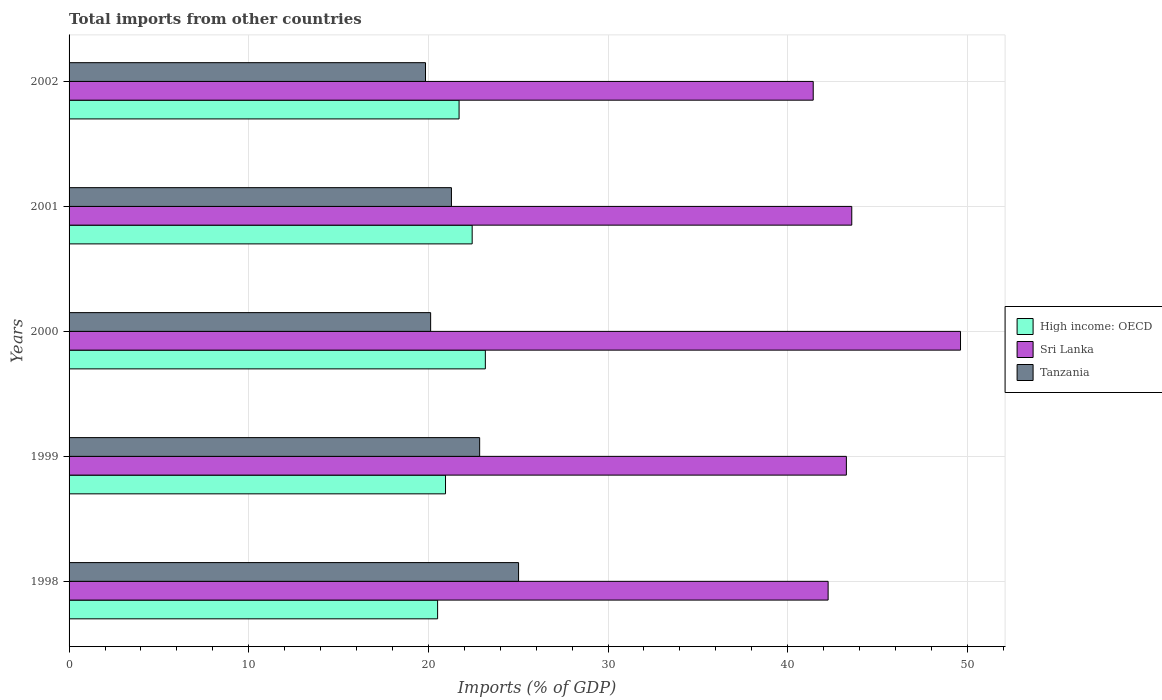How many bars are there on the 2nd tick from the top?
Offer a terse response. 3. How many bars are there on the 2nd tick from the bottom?
Provide a succinct answer. 3. What is the label of the 3rd group of bars from the top?
Keep it short and to the point. 2000. In how many cases, is the number of bars for a given year not equal to the number of legend labels?
Keep it short and to the point. 0. What is the total imports in Sri Lanka in 1999?
Provide a short and direct response. 43.27. Across all years, what is the maximum total imports in Sri Lanka?
Provide a succinct answer. 49.62. Across all years, what is the minimum total imports in High income: OECD?
Provide a short and direct response. 20.51. In which year was the total imports in Tanzania maximum?
Provide a succinct answer. 1998. In which year was the total imports in Tanzania minimum?
Offer a terse response. 2002. What is the total total imports in Tanzania in the graph?
Make the answer very short. 109.12. What is the difference between the total imports in Tanzania in 1998 and that in 1999?
Your response must be concise. 2.17. What is the difference between the total imports in Tanzania in 2000 and the total imports in Sri Lanka in 1999?
Make the answer very short. -23.14. What is the average total imports in Tanzania per year?
Your response must be concise. 21.82. In the year 2001, what is the difference between the total imports in Sri Lanka and total imports in High income: OECD?
Ensure brevity in your answer.  21.13. In how many years, is the total imports in Tanzania greater than 38 %?
Your answer should be compact. 0. What is the ratio of the total imports in Sri Lanka in 1998 to that in 2000?
Provide a succinct answer. 0.85. What is the difference between the highest and the second highest total imports in High income: OECD?
Ensure brevity in your answer.  0.73. What is the difference between the highest and the lowest total imports in High income: OECD?
Offer a terse response. 2.66. Is the sum of the total imports in High income: OECD in 2001 and 2002 greater than the maximum total imports in Tanzania across all years?
Provide a succinct answer. Yes. What does the 2nd bar from the top in 2000 represents?
Provide a succinct answer. Sri Lanka. What does the 3rd bar from the bottom in 2002 represents?
Offer a terse response. Tanzania. Is it the case that in every year, the sum of the total imports in Sri Lanka and total imports in High income: OECD is greater than the total imports in Tanzania?
Your answer should be compact. Yes. How many years are there in the graph?
Your response must be concise. 5. Are the values on the major ticks of X-axis written in scientific E-notation?
Your response must be concise. No. Does the graph contain any zero values?
Provide a short and direct response. No. How many legend labels are there?
Keep it short and to the point. 3. What is the title of the graph?
Your answer should be very brief. Total imports from other countries. Does "Dominica" appear as one of the legend labels in the graph?
Make the answer very short. No. What is the label or title of the X-axis?
Provide a succinct answer. Imports (% of GDP). What is the Imports (% of GDP) in High income: OECD in 1998?
Keep it short and to the point. 20.51. What is the Imports (% of GDP) in Sri Lanka in 1998?
Your response must be concise. 42.25. What is the Imports (% of GDP) in Tanzania in 1998?
Your answer should be compact. 25.02. What is the Imports (% of GDP) in High income: OECD in 1999?
Offer a terse response. 20.95. What is the Imports (% of GDP) in Sri Lanka in 1999?
Give a very brief answer. 43.27. What is the Imports (% of GDP) in Tanzania in 1999?
Give a very brief answer. 22.85. What is the Imports (% of GDP) in High income: OECD in 2000?
Offer a very short reply. 23.17. What is the Imports (% of GDP) of Sri Lanka in 2000?
Offer a terse response. 49.62. What is the Imports (% of GDP) in Tanzania in 2000?
Your answer should be compact. 20.13. What is the Imports (% of GDP) in High income: OECD in 2001?
Offer a terse response. 22.44. What is the Imports (% of GDP) in Sri Lanka in 2001?
Provide a short and direct response. 43.57. What is the Imports (% of GDP) of Tanzania in 2001?
Make the answer very short. 21.28. What is the Imports (% of GDP) of High income: OECD in 2002?
Your answer should be compact. 21.71. What is the Imports (% of GDP) in Sri Lanka in 2002?
Your answer should be compact. 41.42. What is the Imports (% of GDP) of Tanzania in 2002?
Offer a very short reply. 19.84. Across all years, what is the maximum Imports (% of GDP) of High income: OECD?
Keep it short and to the point. 23.17. Across all years, what is the maximum Imports (% of GDP) in Sri Lanka?
Provide a short and direct response. 49.62. Across all years, what is the maximum Imports (% of GDP) of Tanzania?
Offer a terse response. 25.02. Across all years, what is the minimum Imports (% of GDP) of High income: OECD?
Your response must be concise. 20.51. Across all years, what is the minimum Imports (% of GDP) of Sri Lanka?
Offer a very short reply. 41.42. Across all years, what is the minimum Imports (% of GDP) in Tanzania?
Provide a succinct answer. 19.84. What is the total Imports (% of GDP) in High income: OECD in the graph?
Offer a very short reply. 108.79. What is the total Imports (% of GDP) of Sri Lanka in the graph?
Offer a terse response. 220.13. What is the total Imports (% of GDP) of Tanzania in the graph?
Make the answer very short. 109.12. What is the difference between the Imports (% of GDP) of High income: OECD in 1998 and that in 1999?
Give a very brief answer. -0.44. What is the difference between the Imports (% of GDP) of Sri Lanka in 1998 and that in 1999?
Keep it short and to the point. -1.02. What is the difference between the Imports (% of GDP) of Tanzania in 1998 and that in 1999?
Make the answer very short. 2.17. What is the difference between the Imports (% of GDP) of High income: OECD in 1998 and that in 2000?
Ensure brevity in your answer.  -2.66. What is the difference between the Imports (% of GDP) of Sri Lanka in 1998 and that in 2000?
Give a very brief answer. -7.37. What is the difference between the Imports (% of GDP) of Tanzania in 1998 and that in 2000?
Provide a succinct answer. 4.89. What is the difference between the Imports (% of GDP) in High income: OECD in 1998 and that in 2001?
Give a very brief answer. -1.92. What is the difference between the Imports (% of GDP) in Sri Lanka in 1998 and that in 2001?
Provide a short and direct response. -1.32. What is the difference between the Imports (% of GDP) of Tanzania in 1998 and that in 2001?
Make the answer very short. 3.74. What is the difference between the Imports (% of GDP) of High income: OECD in 1998 and that in 2002?
Provide a short and direct response. -1.19. What is the difference between the Imports (% of GDP) in Sri Lanka in 1998 and that in 2002?
Your response must be concise. 0.83. What is the difference between the Imports (% of GDP) of Tanzania in 1998 and that in 2002?
Offer a very short reply. 5.18. What is the difference between the Imports (% of GDP) of High income: OECD in 1999 and that in 2000?
Offer a terse response. -2.22. What is the difference between the Imports (% of GDP) in Sri Lanka in 1999 and that in 2000?
Offer a very short reply. -6.35. What is the difference between the Imports (% of GDP) of Tanzania in 1999 and that in 2000?
Ensure brevity in your answer.  2.73. What is the difference between the Imports (% of GDP) in High income: OECD in 1999 and that in 2001?
Provide a short and direct response. -1.48. What is the difference between the Imports (% of GDP) of Sri Lanka in 1999 and that in 2001?
Make the answer very short. -0.3. What is the difference between the Imports (% of GDP) in Tanzania in 1999 and that in 2001?
Offer a terse response. 1.57. What is the difference between the Imports (% of GDP) of High income: OECD in 1999 and that in 2002?
Give a very brief answer. -0.75. What is the difference between the Imports (% of GDP) of Sri Lanka in 1999 and that in 2002?
Keep it short and to the point. 1.85. What is the difference between the Imports (% of GDP) of Tanzania in 1999 and that in 2002?
Make the answer very short. 3.01. What is the difference between the Imports (% of GDP) of High income: OECD in 2000 and that in 2001?
Your response must be concise. 0.73. What is the difference between the Imports (% of GDP) of Sri Lanka in 2000 and that in 2001?
Ensure brevity in your answer.  6.05. What is the difference between the Imports (% of GDP) of Tanzania in 2000 and that in 2001?
Give a very brief answer. -1.16. What is the difference between the Imports (% of GDP) in High income: OECD in 2000 and that in 2002?
Provide a succinct answer. 1.46. What is the difference between the Imports (% of GDP) in Sri Lanka in 2000 and that in 2002?
Give a very brief answer. 8.2. What is the difference between the Imports (% of GDP) of Tanzania in 2000 and that in 2002?
Offer a terse response. 0.29. What is the difference between the Imports (% of GDP) of High income: OECD in 2001 and that in 2002?
Your answer should be very brief. 0.73. What is the difference between the Imports (% of GDP) of Sri Lanka in 2001 and that in 2002?
Offer a very short reply. 2.15. What is the difference between the Imports (% of GDP) of Tanzania in 2001 and that in 2002?
Provide a succinct answer. 1.44. What is the difference between the Imports (% of GDP) of High income: OECD in 1998 and the Imports (% of GDP) of Sri Lanka in 1999?
Your response must be concise. -22.75. What is the difference between the Imports (% of GDP) of High income: OECD in 1998 and the Imports (% of GDP) of Tanzania in 1999?
Keep it short and to the point. -2.34. What is the difference between the Imports (% of GDP) of Sri Lanka in 1998 and the Imports (% of GDP) of Tanzania in 1999?
Your response must be concise. 19.4. What is the difference between the Imports (% of GDP) in High income: OECD in 1998 and the Imports (% of GDP) in Sri Lanka in 2000?
Give a very brief answer. -29.11. What is the difference between the Imports (% of GDP) in High income: OECD in 1998 and the Imports (% of GDP) in Tanzania in 2000?
Make the answer very short. 0.39. What is the difference between the Imports (% of GDP) of Sri Lanka in 1998 and the Imports (% of GDP) of Tanzania in 2000?
Provide a succinct answer. 22.13. What is the difference between the Imports (% of GDP) of High income: OECD in 1998 and the Imports (% of GDP) of Sri Lanka in 2001?
Offer a very short reply. -23.05. What is the difference between the Imports (% of GDP) in High income: OECD in 1998 and the Imports (% of GDP) in Tanzania in 2001?
Your response must be concise. -0.77. What is the difference between the Imports (% of GDP) of Sri Lanka in 1998 and the Imports (% of GDP) of Tanzania in 2001?
Your answer should be very brief. 20.97. What is the difference between the Imports (% of GDP) in High income: OECD in 1998 and the Imports (% of GDP) in Sri Lanka in 2002?
Provide a short and direct response. -20.91. What is the difference between the Imports (% of GDP) in High income: OECD in 1998 and the Imports (% of GDP) in Tanzania in 2002?
Your answer should be compact. 0.67. What is the difference between the Imports (% of GDP) in Sri Lanka in 1998 and the Imports (% of GDP) in Tanzania in 2002?
Keep it short and to the point. 22.41. What is the difference between the Imports (% of GDP) in High income: OECD in 1999 and the Imports (% of GDP) in Sri Lanka in 2000?
Ensure brevity in your answer.  -28.67. What is the difference between the Imports (% of GDP) of High income: OECD in 1999 and the Imports (% of GDP) of Tanzania in 2000?
Give a very brief answer. 0.83. What is the difference between the Imports (% of GDP) of Sri Lanka in 1999 and the Imports (% of GDP) of Tanzania in 2000?
Provide a short and direct response. 23.14. What is the difference between the Imports (% of GDP) of High income: OECD in 1999 and the Imports (% of GDP) of Sri Lanka in 2001?
Offer a very short reply. -22.61. What is the difference between the Imports (% of GDP) of High income: OECD in 1999 and the Imports (% of GDP) of Tanzania in 2001?
Ensure brevity in your answer.  -0.33. What is the difference between the Imports (% of GDP) in Sri Lanka in 1999 and the Imports (% of GDP) in Tanzania in 2001?
Make the answer very short. 21.98. What is the difference between the Imports (% of GDP) in High income: OECD in 1999 and the Imports (% of GDP) in Sri Lanka in 2002?
Your response must be concise. -20.47. What is the difference between the Imports (% of GDP) in High income: OECD in 1999 and the Imports (% of GDP) in Tanzania in 2002?
Offer a very short reply. 1.11. What is the difference between the Imports (% of GDP) of Sri Lanka in 1999 and the Imports (% of GDP) of Tanzania in 2002?
Provide a short and direct response. 23.43. What is the difference between the Imports (% of GDP) in High income: OECD in 2000 and the Imports (% of GDP) in Sri Lanka in 2001?
Provide a short and direct response. -20.4. What is the difference between the Imports (% of GDP) in High income: OECD in 2000 and the Imports (% of GDP) in Tanzania in 2001?
Your answer should be compact. 1.89. What is the difference between the Imports (% of GDP) of Sri Lanka in 2000 and the Imports (% of GDP) of Tanzania in 2001?
Provide a succinct answer. 28.34. What is the difference between the Imports (% of GDP) of High income: OECD in 2000 and the Imports (% of GDP) of Sri Lanka in 2002?
Offer a very short reply. -18.25. What is the difference between the Imports (% of GDP) of High income: OECD in 2000 and the Imports (% of GDP) of Tanzania in 2002?
Your answer should be very brief. 3.33. What is the difference between the Imports (% of GDP) of Sri Lanka in 2000 and the Imports (% of GDP) of Tanzania in 2002?
Your answer should be very brief. 29.78. What is the difference between the Imports (% of GDP) of High income: OECD in 2001 and the Imports (% of GDP) of Sri Lanka in 2002?
Ensure brevity in your answer.  -18.98. What is the difference between the Imports (% of GDP) of High income: OECD in 2001 and the Imports (% of GDP) of Tanzania in 2002?
Offer a very short reply. 2.6. What is the difference between the Imports (% of GDP) in Sri Lanka in 2001 and the Imports (% of GDP) in Tanzania in 2002?
Provide a short and direct response. 23.73. What is the average Imports (% of GDP) in High income: OECD per year?
Your response must be concise. 21.76. What is the average Imports (% of GDP) of Sri Lanka per year?
Your response must be concise. 44.03. What is the average Imports (% of GDP) in Tanzania per year?
Your answer should be compact. 21.82. In the year 1998, what is the difference between the Imports (% of GDP) of High income: OECD and Imports (% of GDP) of Sri Lanka?
Offer a terse response. -21.74. In the year 1998, what is the difference between the Imports (% of GDP) in High income: OECD and Imports (% of GDP) in Tanzania?
Your answer should be compact. -4.51. In the year 1998, what is the difference between the Imports (% of GDP) in Sri Lanka and Imports (% of GDP) in Tanzania?
Give a very brief answer. 17.23. In the year 1999, what is the difference between the Imports (% of GDP) of High income: OECD and Imports (% of GDP) of Sri Lanka?
Provide a short and direct response. -22.31. In the year 1999, what is the difference between the Imports (% of GDP) of Sri Lanka and Imports (% of GDP) of Tanzania?
Give a very brief answer. 20.41. In the year 2000, what is the difference between the Imports (% of GDP) of High income: OECD and Imports (% of GDP) of Sri Lanka?
Offer a terse response. -26.45. In the year 2000, what is the difference between the Imports (% of GDP) of High income: OECD and Imports (% of GDP) of Tanzania?
Keep it short and to the point. 3.05. In the year 2000, what is the difference between the Imports (% of GDP) of Sri Lanka and Imports (% of GDP) of Tanzania?
Ensure brevity in your answer.  29.49. In the year 2001, what is the difference between the Imports (% of GDP) of High income: OECD and Imports (% of GDP) of Sri Lanka?
Keep it short and to the point. -21.13. In the year 2001, what is the difference between the Imports (% of GDP) of High income: OECD and Imports (% of GDP) of Tanzania?
Provide a short and direct response. 1.15. In the year 2001, what is the difference between the Imports (% of GDP) in Sri Lanka and Imports (% of GDP) in Tanzania?
Give a very brief answer. 22.28. In the year 2002, what is the difference between the Imports (% of GDP) in High income: OECD and Imports (% of GDP) in Sri Lanka?
Provide a succinct answer. -19.71. In the year 2002, what is the difference between the Imports (% of GDP) of High income: OECD and Imports (% of GDP) of Tanzania?
Make the answer very short. 1.87. In the year 2002, what is the difference between the Imports (% of GDP) in Sri Lanka and Imports (% of GDP) in Tanzania?
Ensure brevity in your answer.  21.58. What is the ratio of the Imports (% of GDP) of High income: OECD in 1998 to that in 1999?
Provide a short and direct response. 0.98. What is the ratio of the Imports (% of GDP) of Sri Lanka in 1998 to that in 1999?
Your answer should be compact. 0.98. What is the ratio of the Imports (% of GDP) of Tanzania in 1998 to that in 1999?
Your answer should be very brief. 1.09. What is the ratio of the Imports (% of GDP) in High income: OECD in 1998 to that in 2000?
Offer a very short reply. 0.89. What is the ratio of the Imports (% of GDP) of Sri Lanka in 1998 to that in 2000?
Provide a succinct answer. 0.85. What is the ratio of the Imports (% of GDP) of Tanzania in 1998 to that in 2000?
Provide a succinct answer. 1.24. What is the ratio of the Imports (% of GDP) of High income: OECD in 1998 to that in 2001?
Provide a short and direct response. 0.91. What is the ratio of the Imports (% of GDP) in Sri Lanka in 1998 to that in 2001?
Provide a succinct answer. 0.97. What is the ratio of the Imports (% of GDP) of Tanzania in 1998 to that in 2001?
Give a very brief answer. 1.18. What is the ratio of the Imports (% of GDP) in High income: OECD in 1998 to that in 2002?
Ensure brevity in your answer.  0.94. What is the ratio of the Imports (% of GDP) in Sri Lanka in 1998 to that in 2002?
Your response must be concise. 1.02. What is the ratio of the Imports (% of GDP) in Tanzania in 1998 to that in 2002?
Offer a very short reply. 1.26. What is the ratio of the Imports (% of GDP) in High income: OECD in 1999 to that in 2000?
Offer a terse response. 0.9. What is the ratio of the Imports (% of GDP) in Sri Lanka in 1999 to that in 2000?
Offer a terse response. 0.87. What is the ratio of the Imports (% of GDP) in Tanzania in 1999 to that in 2000?
Your answer should be very brief. 1.14. What is the ratio of the Imports (% of GDP) of High income: OECD in 1999 to that in 2001?
Ensure brevity in your answer.  0.93. What is the ratio of the Imports (% of GDP) of Tanzania in 1999 to that in 2001?
Keep it short and to the point. 1.07. What is the ratio of the Imports (% of GDP) in High income: OECD in 1999 to that in 2002?
Your answer should be compact. 0.97. What is the ratio of the Imports (% of GDP) in Sri Lanka in 1999 to that in 2002?
Provide a short and direct response. 1.04. What is the ratio of the Imports (% of GDP) in Tanzania in 1999 to that in 2002?
Offer a terse response. 1.15. What is the ratio of the Imports (% of GDP) of High income: OECD in 2000 to that in 2001?
Provide a short and direct response. 1.03. What is the ratio of the Imports (% of GDP) in Sri Lanka in 2000 to that in 2001?
Keep it short and to the point. 1.14. What is the ratio of the Imports (% of GDP) in Tanzania in 2000 to that in 2001?
Your answer should be compact. 0.95. What is the ratio of the Imports (% of GDP) of High income: OECD in 2000 to that in 2002?
Ensure brevity in your answer.  1.07. What is the ratio of the Imports (% of GDP) in Sri Lanka in 2000 to that in 2002?
Your answer should be very brief. 1.2. What is the ratio of the Imports (% of GDP) of Tanzania in 2000 to that in 2002?
Ensure brevity in your answer.  1.01. What is the ratio of the Imports (% of GDP) of High income: OECD in 2001 to that in 2002?
Provide a short and direct response. 1.03. What is the ratio of the Imports (% of GDP) in Sri Lanka in 2001 to that in 2002?
Offer a terse response. 1.05. What is the ratio of the Imports (% of GDP) of Tanzania in 2001 to that in 2002?
Your answer should be very brief. 1.07. What is the difference between the highest and the second highest Imports (% of GDP) in High income: OECD?
Give a very brief answer. 0.73. What is the difference between the highest and the second highest Imports (% of GDP) in Sri Lanka?
Provide a succinct answer. 6.05. What is the difference between the highest and the second highest Imports (% of GDP) of Tanzania?
Your response must be concise. 2.17. What is the difference between the highest and the lowest Imports (% of GDP) in High income: OECD?
Provide a short and direct response. 2.66. What is the difference between the highest and the lowest Imports (% of GDP) in Sri Lanka?
Keep it short and to the point. 8.2. What is the difference between the highest and the lowest Imports (% of GDP) of Tanzania?
Offer a very short reply. 5.18. 